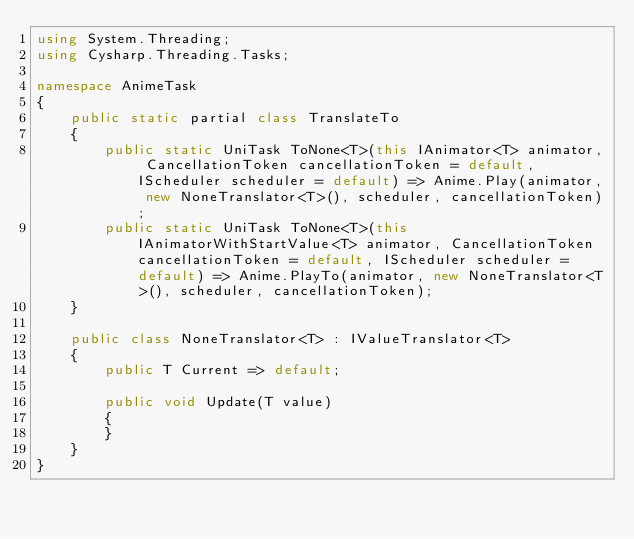<code> <loc_0><loc_0><loc_500><loc_500><_C#_>using System.Threading;
using Cysharp.Threading.Tasks;

namespace AnimeTask
{
    public static partial class TranslateTo
    {
        public static UniTask ToNone<T>(this IAnimator<T> animator, CancellationToken cancellationToken = default, IScheduler scheduler = default) => Anime.Play(animator, new NoneTranslator<T>(), scheduler, cancellationToken);
        public static UniTask ToNone<T>(this IAnimatorWithStartValue<T> animator, CancellationToken cancellationToken = default, IScheduler scheduler = default) => Anime.PlayTo(animator, new NoneTranslator<T>(), scheduler, cancellationToken);
    }

    public class NoneTranslator<T> : IValueTranslator<T>
    {
        public T Current => default;

        public void Update(T value)
        {
        }
    }
}</code> 